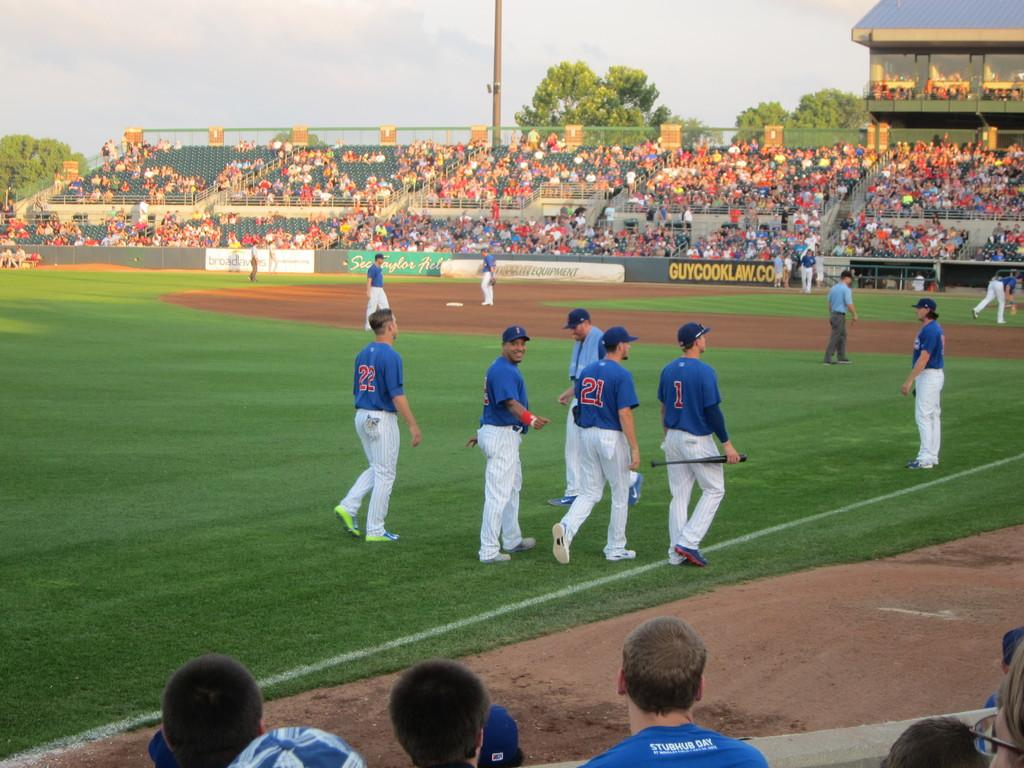<image>
Share a concise interpretation of the image provided. guycooklaw.com sponsors the field that the people are playing baseball on 